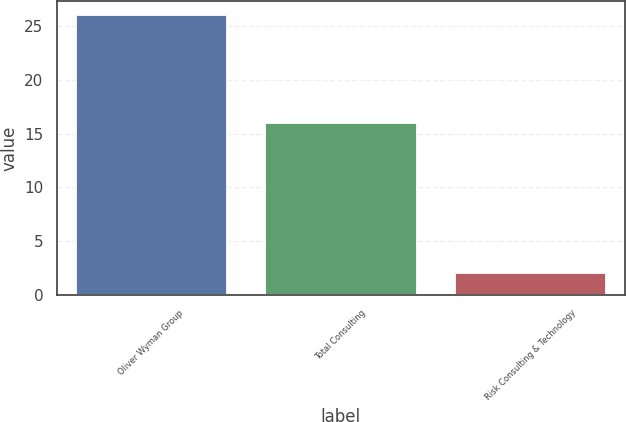<chart> <loc_0><loc_0><loc_500><loc_500><bar_chart><fcel>Oliver Wyman Group<fcel>Total Consulting<fcel>Risk Consulting & Technology<nl><fcel>26<fcel>16<fcel>2<nl></chart> 